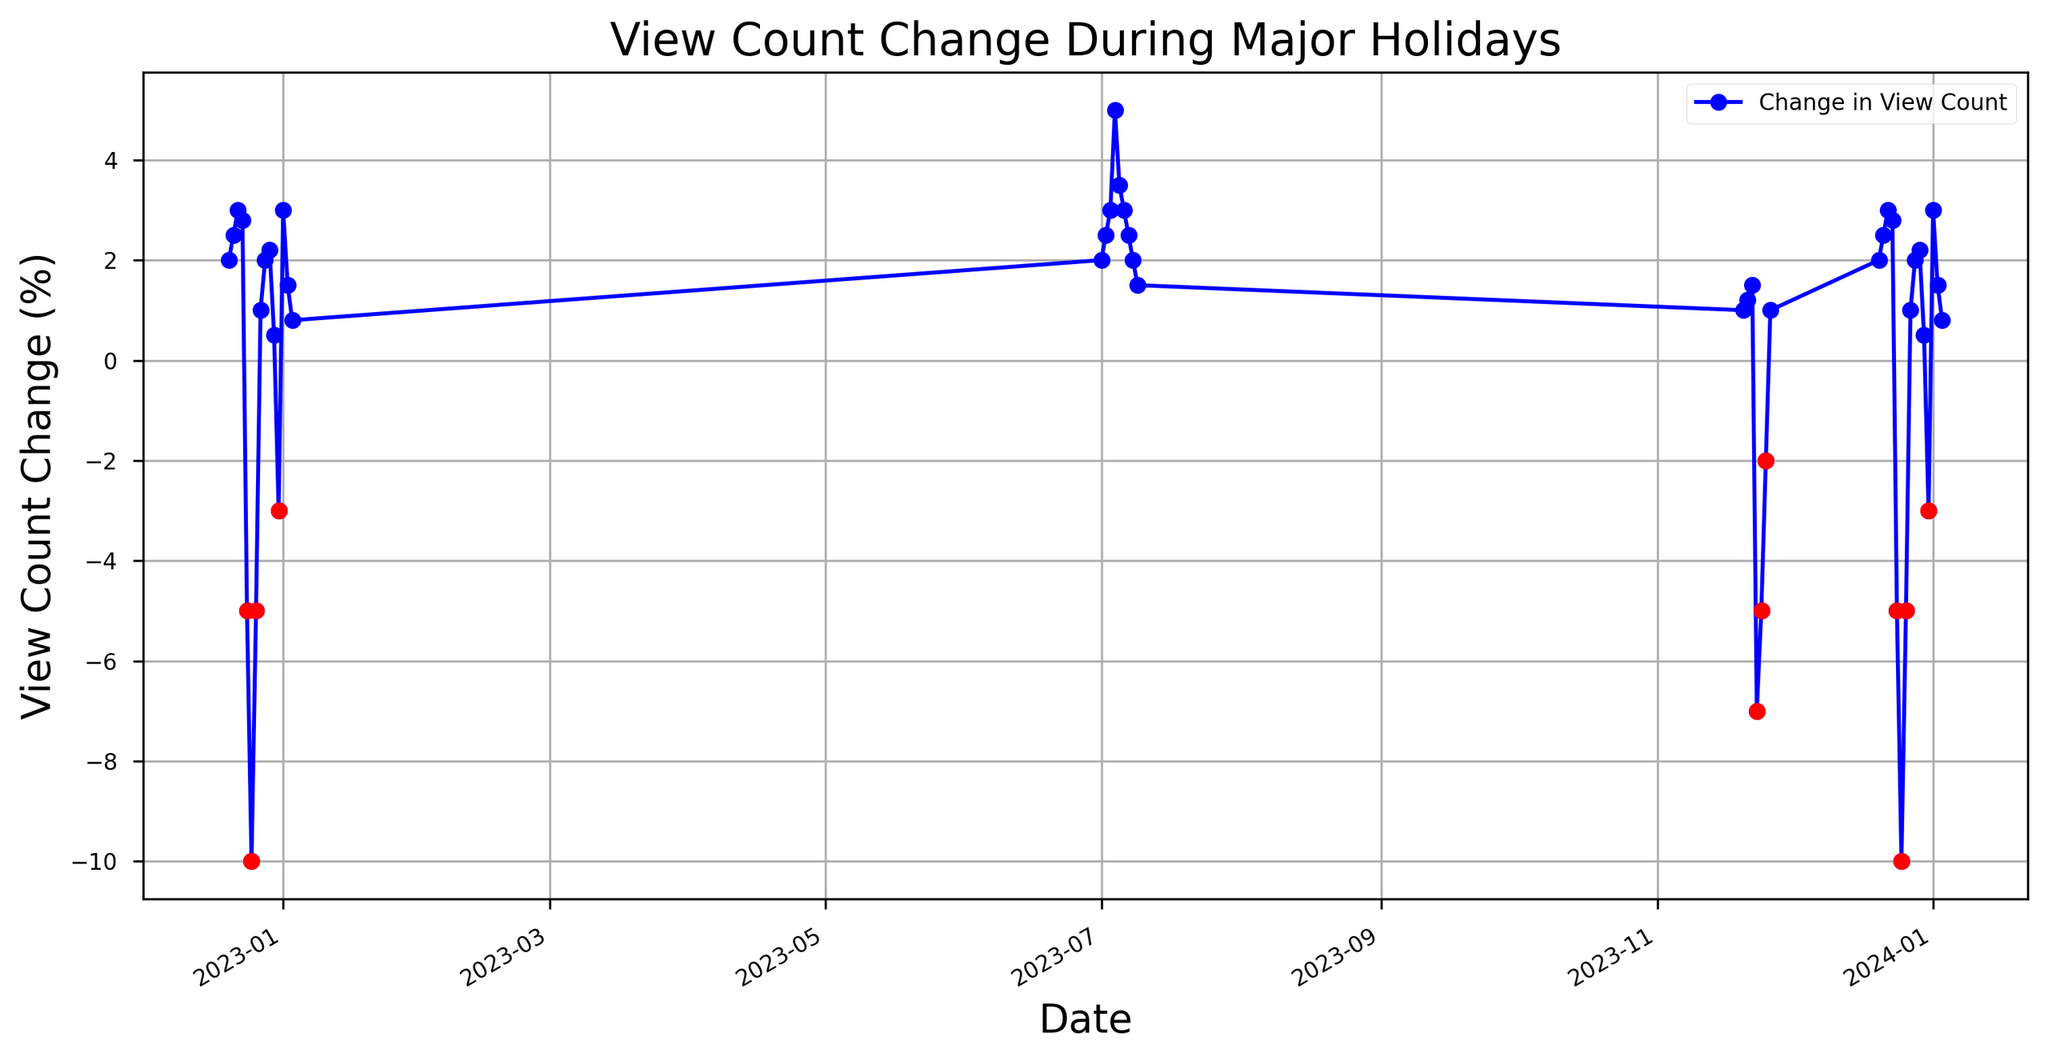What dates show the largest drop in view counts and by how much? Look at the figure and locate the largest negative values. The two dates with the largest drops are 2022-12-25 and 2023-12-25, with both drops being -10%.
Answer: 2022-12-25 and 2023-12-25, by 10% Which date shows the highest increase in view counts? Examine the data points and identify the date with the highest positive value. The highest increase is on 2023-07-04 with a 5% increase.
Answer: 2023-07-04 Compare the view count changes on Christmas and New Year's Day. What do you observe? Check the values on 2022-12-25/2023-12-25 (Christmas) and 2023-01-01/2024-01-01 (New Year's Day). Christmas shows a 10% decrease, while New Year's Day reflects a 3% increase.
Answer: Christmas: -10%, New Year's Day: +3% On what dates do we observe view count changes that are lower than the average in December? Calculate the average view count change in December and identify dates with values below this average. The average increase in December (excluding extreme specific holidays) is about 0.7%. Dates below average include 2022-12-24, 2022-12-25, 2022-12-26, 2022-12-31, 2023-12-24, 2023-12-25, 2023-12-26, and 2023-12-31.
Answer: 2022-12-24, 2022-12-25, 2022-12-26, 2022-12-31, 2023-12-24, 2023-12-25, 2023-12-26, 2023-12-31 How does the view count on Independence Day 2023 compare to regular days in July 2023? Compare the view count change on 2023-07-04 (Independence Day) and other dates in July 2023. On Independence Day, the increase is 5%, which is higher than other days in July which range from 1.5% to 3.5%.
Answer: Higher on Independence Day Identify the date with the smallest positive change and its value. Scan through the positive changes in the data. The smallest positive change is on 2022-12-30 and 2023-12-30, with a 0.5% increase.
Answer: 2022-12-30 and 2023-12-30, 0.5% Comparing Thanksgiving with the day after, what trend do you notice? Look at view counts on 2023-11-23 (Thanksgiving) and 2023-11-24. Thanksgiving shows a -7% change while the day after shows a -5% change, indicating both have negative values but the drop is less the day after.
Answer: Decrease on both days, less on the day after Thanksgiving Which periods show consistent positive increases in view counts? Identify stretches of consecutive positive values. Periods include 2022-12-20 to 2022-12-23, 2023-07-01 to 2023-07-04, and 2023-12-20 to 2023-12-23.
Answer: 2022-12-20 to 2022-12-23, 2023-07-01 to 2023-07-04, and 2023-12-20 to 2023-12-23 